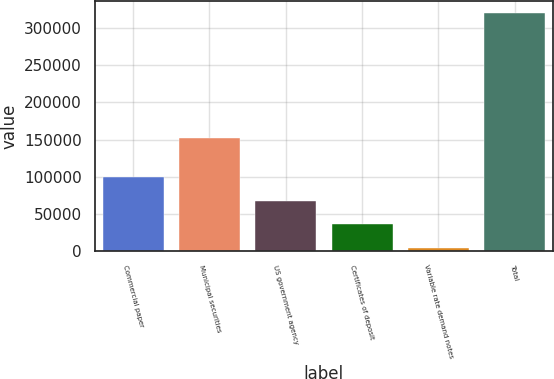Convert chart. <chart><loc_0><loc_0><loc_500><loc_500><bar_chart><fcel>Commercial paper<fcel>Municipal securities<fcel>US government agency<fcel>Certificates of deposit<fcel>Variable rate demand notes<fcel>Total<nl><fcel>99025.5<fcel>151690<fcel>67352<fcel>35678.5<fcel>4005<fcel>320740<nl></chart> 